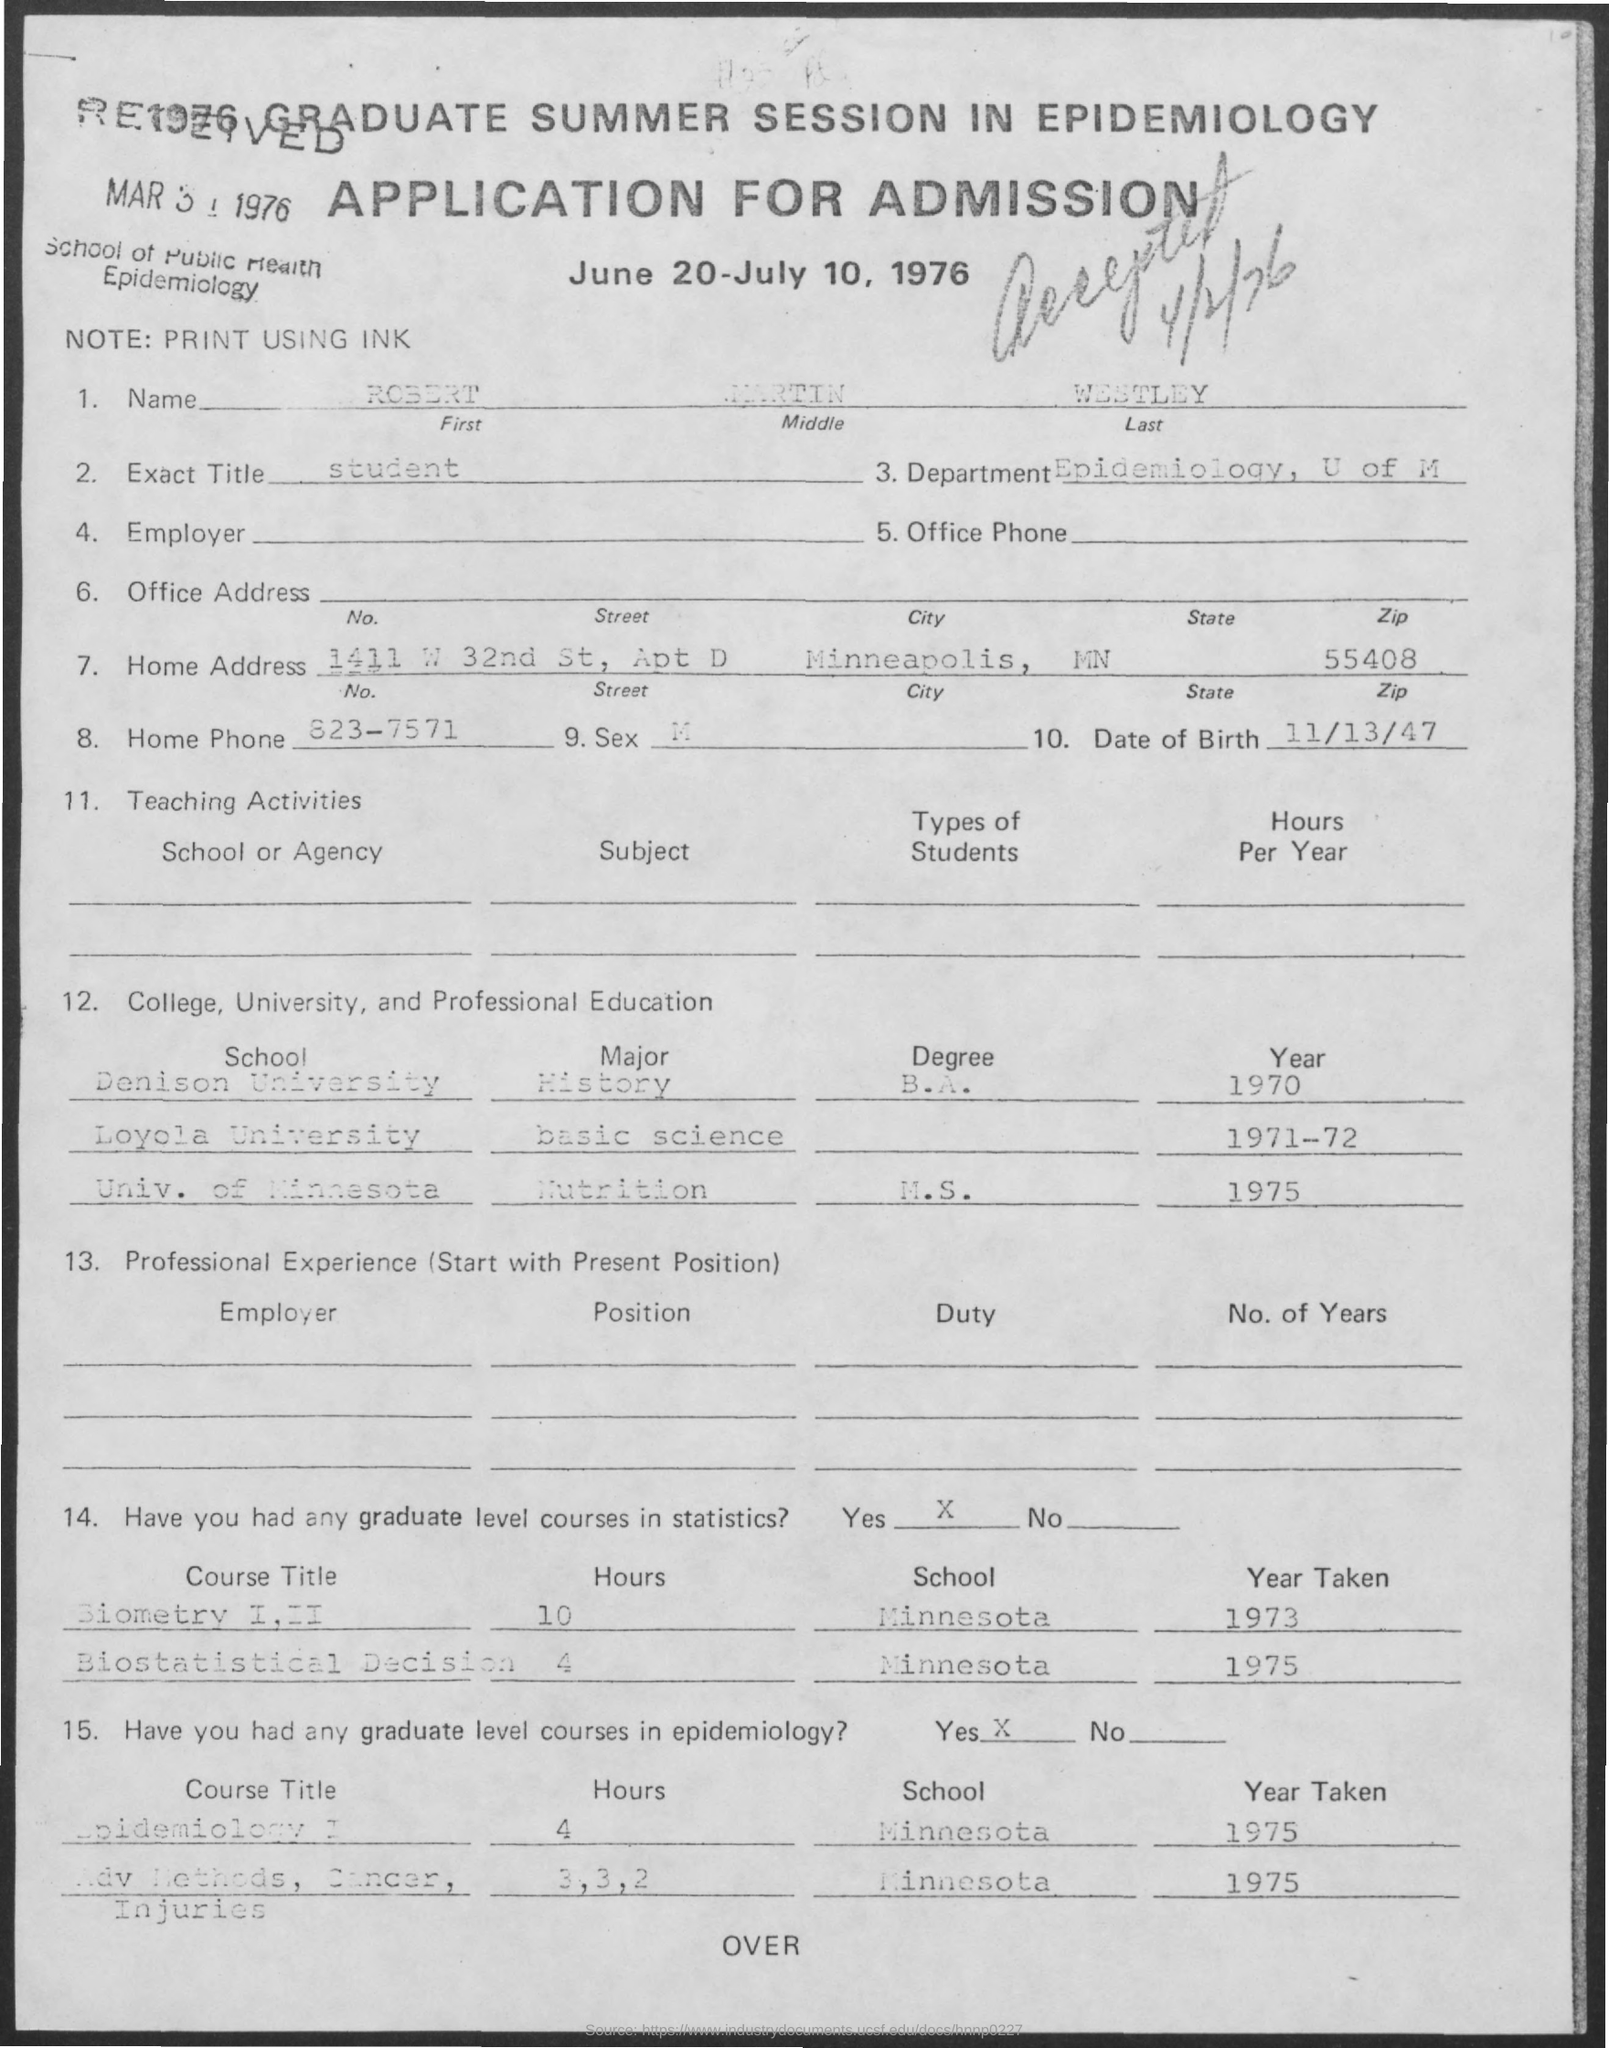Which universities did the applicant attend and what were the majors? The applicant attended Denison University majoring in History, Loyola University for Basic Science, and the University of Minnesota specializing in Nutrition. 